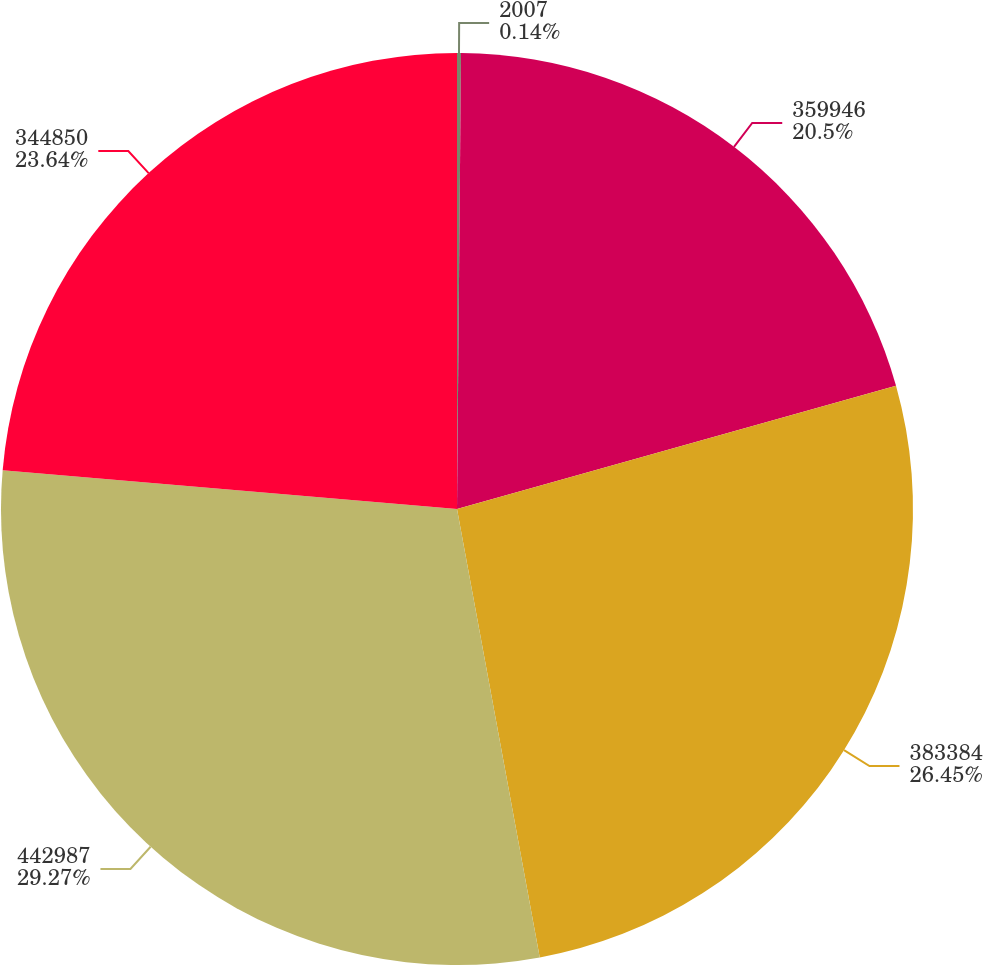Convert chart to OTSL. <chart><loc_0><loc_0><loc_500><loc_500><pie_chart><fcel>2007<fcel>359946<fcel>383384<fcel>442987<fcel>344850<nl><fcel>0.14%<fcel>20.5%<fcel>26.45%<fcel>29.26%<fcel>23.64%<nl></chart> 